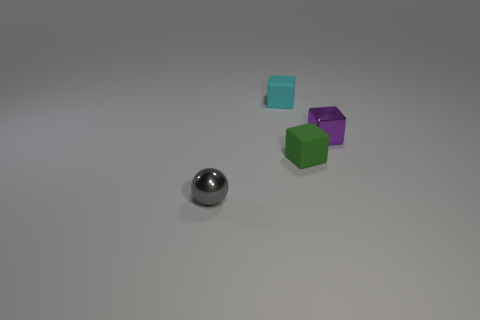Subtract all tiny rubber blocks. How many blocks are left? 1 Add 1 green objects. How many objects exist? 5 Subtract 0 gray cylinders. How many objects are left? 4 Subtract all cubes. How many objects are left? 1 Subtract 1 blocks. How many blocks are left? 2 Subtract all gray cubes. Subtract all cyan balls. How many cubes are left? 3 Subtract all cyan cylinders. How many purple spheres are left? 0 Subtract all small yellow metal spheres. Subtract all purple metallic objects. How many objects are left? 3 Add 4 tiny cyan cubes. How many tiny cyan cubes are left? 5 Add 2 gray spheres. How many gray spheres exist? 3 